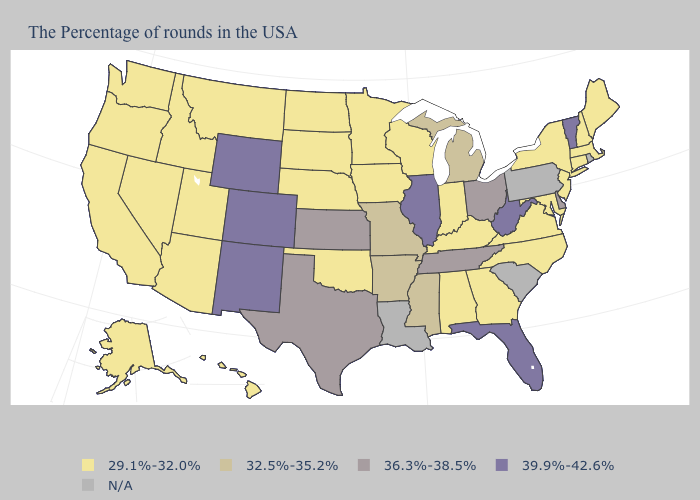Name the states that have a value in the range 29.1%-32.0%?
Short answer required. Maine, Massachusetts, New Hampshire, Connecticut, New York, New Jersey, Maryland, Virginia, North Carolina, Georgia, Kentucky, Indiana, Alabama, Wisconsin, Minnesota, Iowa, Nebraska, Oklahoma, South Dakota, North Dakota, Utah, Montana, Arizona, Idaho, Nevada, California, Washington, Oregon, Alaska, Hawaii. Among the states that border Maryland , which have the lowest value?
Concise answer only. Virginia. Name the states that have a value in the range 29.1%-32.0%?
Keep it brief. Maine, Massachusetts, New Hampshire, Connecticut, New York, New Jersey, Maryland, Virginia, North Carolina, Georgia, Kentucky, Indiana, Alabama, Wisconsin, Minnesota, Iowa, Nebraska, Oklahoma, South Dakota, North Dakota, Utah, Montana, Arizona, Idaho, Nevada, California, Washington, Oregon, Alaska, Hawaii. What is the lowest value in the MidWest?
Write a very short answer. 29.1%-32.0%. Which states have the highest value in the USA?
Write a very short answer. Vermont, West Virginia, Florida, Illinois, Wyoming, Colorado, New Mexico. Does the first symbol in the legend represent the smallest category?
Be succinct. Yes. Among the states that border Kentucky , which have the lowest value?
Be succinct. Virginia, Indiana. Name the states that have a value in the range 29.1%-32.0%?
Quick response, please. Maine, Massachusetts, New Hampshire, Connecticut, New York, New Jersey, Maryland, Virginia, North Carolina, Georgia, Kentucky, Indiana, Alabama, Wisconsin, Minnesota, Iowa, Nebraska, Oklahoma, South Dakota, North Dakota, Utah, Montana, Arizona, Idaho, Nevada, California, Washington, Oregon, Alaska, Hawaii. What is the value of Maryland?
Answer briefly. 29.1%-32.0%. What is the highest value in the South ?
Write a very short answer. 39.9%-42.6%. Among the states that border Ohio , which have the lowest value?
Short answer required. Kentucky, Indiana. What is the highest value in the USA?
Answer briefly. 39.9%-42.6%. 